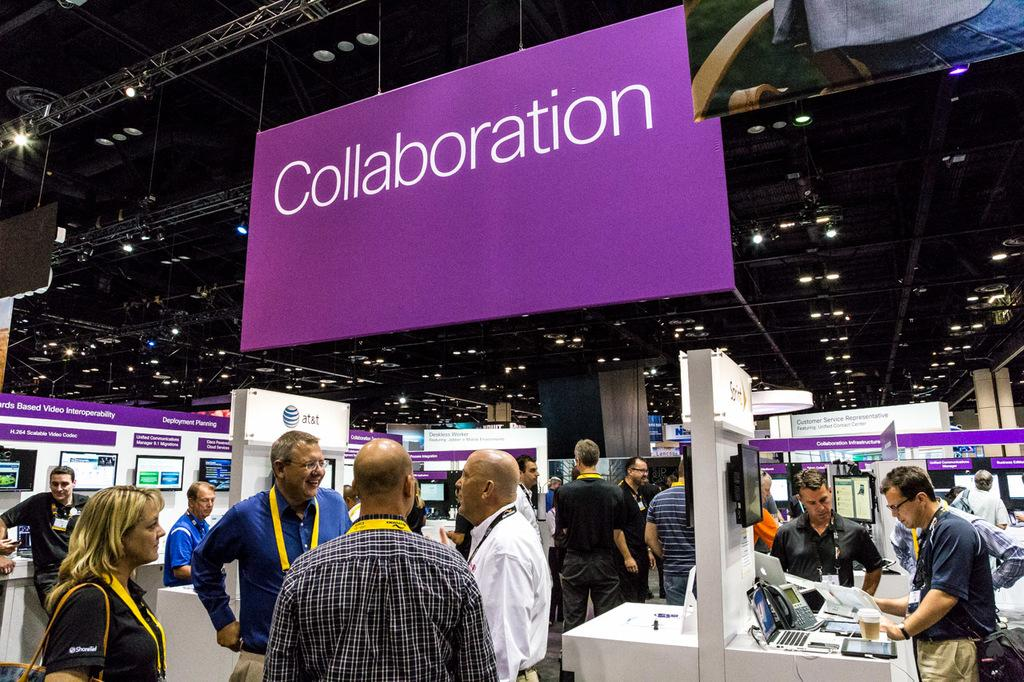Provide a one-sentence caption for the provided image. An event of some sort with a sign saying collaboration. 